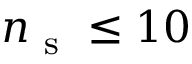<formula> <loc_0><loc_0><loc_500><loc_500>n _ { s } \leq 1 0</formula> 